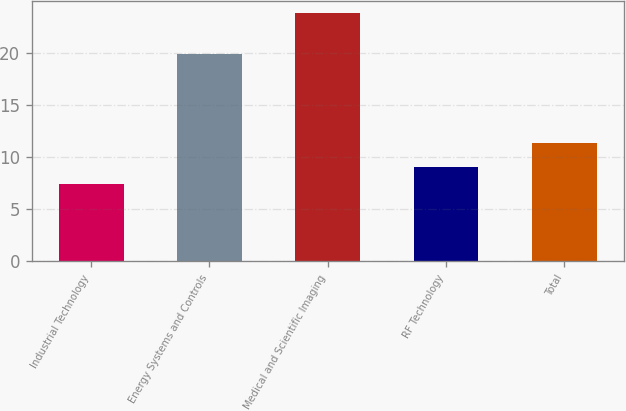Convert chart to OTSL. <chart><loc_0><loc_0><loc_500><loc_500><bar_chart><fcel>Industrial Technology<fcel>Energy Systems and Controls<fcel>Medical and Scientific Imaging<fcel>RF Technology<fcel>Total<nl><fcel>7.4<fcel>19.9<fcel>23.8<fcel>9.04<fcel>11.4<nl></chart> 